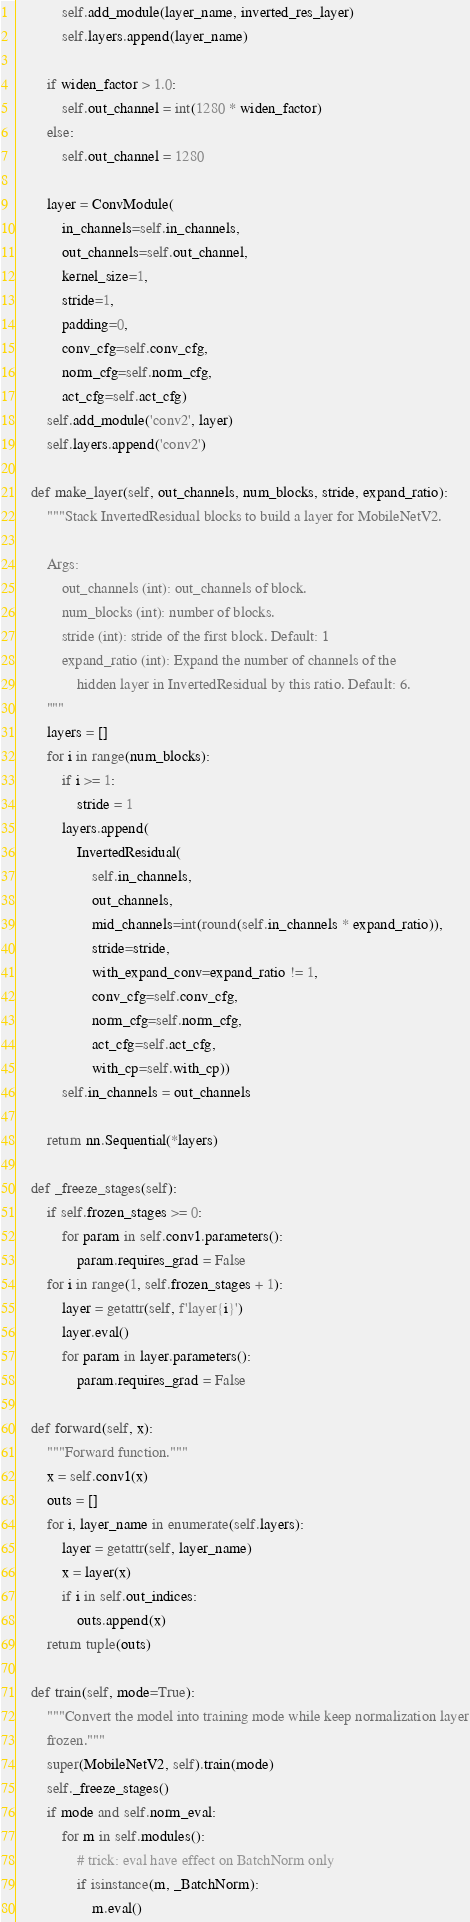Convert code to text. <code><loc_0><loc_0><loc_500><loc_500><_Python_>            self.add_module(layer_name, inverted_res_layer)
            self.layers.append(layer_name)

        if widen_factor > 1.0:
            self.out_channel = int(1280 * widen_factor)
        else:
            self.out_channel = 1280

        layer = ConvModule(
            in_channels=self.in_channels,
            out_channels=self.out_channel,
            kernel_size=1,
            stride=1,
            padding=0,
            conv_cfg=self.conv_cfg,
            norm_cfg=self.norm_cfg,
            act_cfg=self.act_cfg)
        self.add_module('conv2', layer)
        self.layers.append('conv2')

    def make_layer(self, out_channels, num_blocks, stride, expand_ratio):
        """Stack InvertedResidual blocks to build a layer for MobileNetV2.

        Args:
            out_channels (int): out_channels of block.
            num_blocks (int): number of blocks.
            stride (int): stride of the first block. Default: 1
            expand_ratio (int): Expand the number of channels of the
                hidden layer in InvertedResidual by this ratio. Default: 6.
        """
        layers = []
        for i in range(num_blocks):
            if i >= 1:
                stride = 1
            layers.append(
                InvertedResidual(
                    self.in_channels,
                    out_channels,
                    mid_channels=int(round(self.in_channels * expand_ratio)),
                    stride=stride,
                    with_expand_conv=expand_ratio != 1,
                    conv_cfg=self.conv_cfg,
                    norm_cfg=self.norm_cfg,
                    act_cfg=self.act_cfg,
                    with_cp=self.with_cp))
            self.in_channels = out_channels

        return nn.Sequential(*layers)

    def _freeze_stages(self):
        if self.frozen_stages >= 0:
            for param in self.conv1.parameters():
                param.requires_grad = False
        for i in range(1, self.frozen_stages + 1):
            layer = getattr(self, f'layer{i}')
            layer.eval()
            for param in layer.parameters():
                param.requires_grad = False

    def forward(self, x):
        """Forward function."""
        x = self.conv1(x)
        outs = []
        for i, layer_name in enumerate(self.layers):
            layer = getattr(self, layer_name)
            x = layer(x)
            if i in self.out_indices:
                outs.append(x)
        return tuple(outs)

    def train(self, mode=True):
        """Convert the model into training mode while keep normalization layer
        frozen."""
        super(MobileNetV2, self).train(mode)
        self._freeze_stages()
        if mode and self.norm_eval:
            for m in self.modules():
                # trick: eval have effect on BatchNorm only
                if isinstance(m, _BatchNorm):
                    m.eval()
</code> 